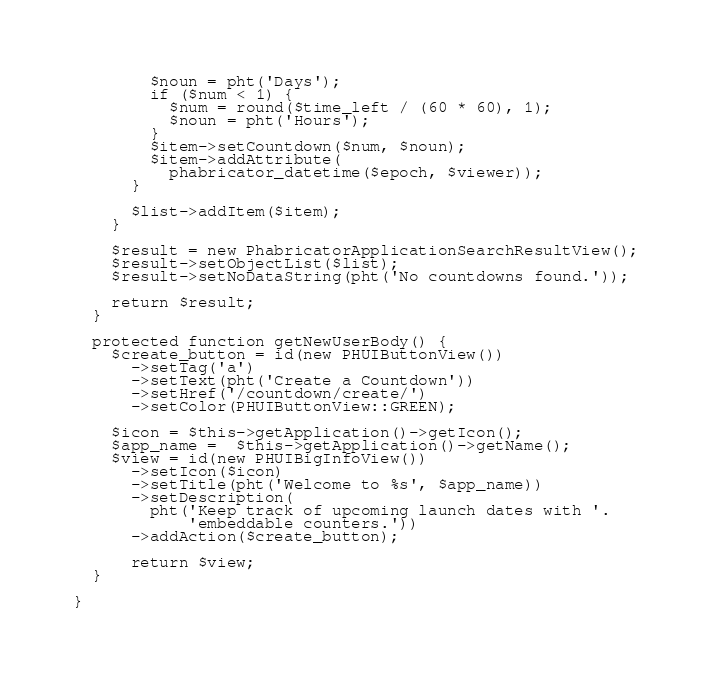Convert code to text. <code><loc_0><loc_0><loc_500><loc_500><_PHP_>        $noun = pht('Days');
        if ($num < 1) {
          $num = round($time_left / (60 * 60), 1);
          $noun = pht('Hours');
        }
        $item->setCountdown($num, $noun);
        $item->addAttribute(
          phabricator_datetime($epoch, $viewer));
      }

      $list->addItem($item);
    }

    $result = new PhabricatorApplicationSearchResultView();
    $result->setObjectList($list);
    $result->setNoDataString(pht('No countdowns found.'));

    return $result;
  }

  protected function getNewUserBody() {
    $create_button = id(new PHUIButtonView())
      ->setTag('a')
      ->setText(pht('Create a Countdown'))
      ->setHref('/countdown/create/')
      ->setColor(PHUIButtonView::GREEN);

    $icon = $this->getApplication()->getIcon();
    $app_name =  $this->getApplication()->getName();
    $view = id(new PHUIBigInfoView())
      ->setIcon($icon)
      ->setTitle(pht('Welcome to %s', $app_name))
      ->setDescription(
        pht('Keep track of upcoming launch dates with '.
            'embeddable counters.'))
      ->addAction($create_button);

      return $view;
  }

}
</code> 